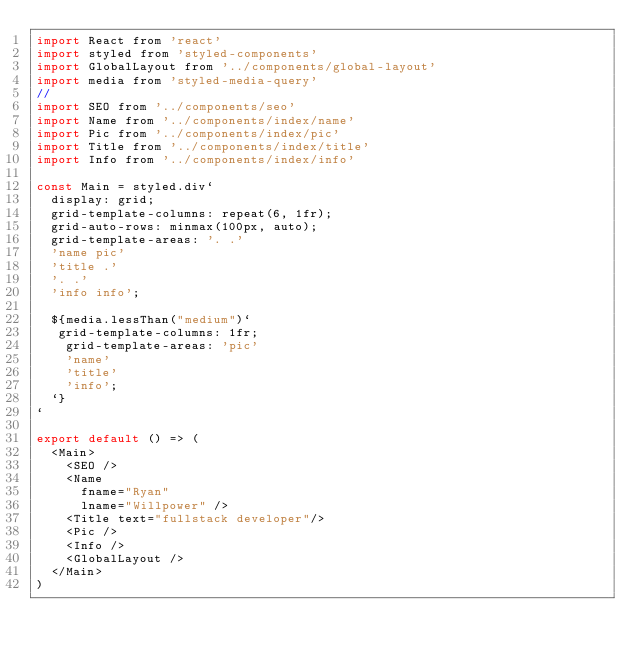<code> <loc_0><loc_0><loc_500><loc_500><_JavaScript_>import React from 'react'
import styled from 'styled-components'
import GlobalLayout from '../components/global-layout'
import media from 'styled-media-query'
//
import SEO from '../components/seo'
import Name from '../components/index/name'
import Pic from '../components/index/pic'
import Title from '../components/index/title'
import Info from '../components/index/info'

const Main = styled.div`
  display: grid;
  grid-template-columns: repeat(6, 1fr);
  grid-auto-rows: minmax(100px, auto);
  grid-template-areas: '. .'
  'name pic'
  'title .'
  '. .'
  'info info';

  ${media.lessThan("medium")`
   grid-template-columns: 1fr;
    grid-template-areas: 'pic'
    'name'
    'title'
    'info';
  `}
`

export default () => (
  <Main>
    <SEO />
    <Name
      fname="Ryan"
      lname="Willpower" />
    <Title text="fullstack developer"/>
    <Pic />
    <Info />
    <GlobalLayout />
  </Main>
)</code> 